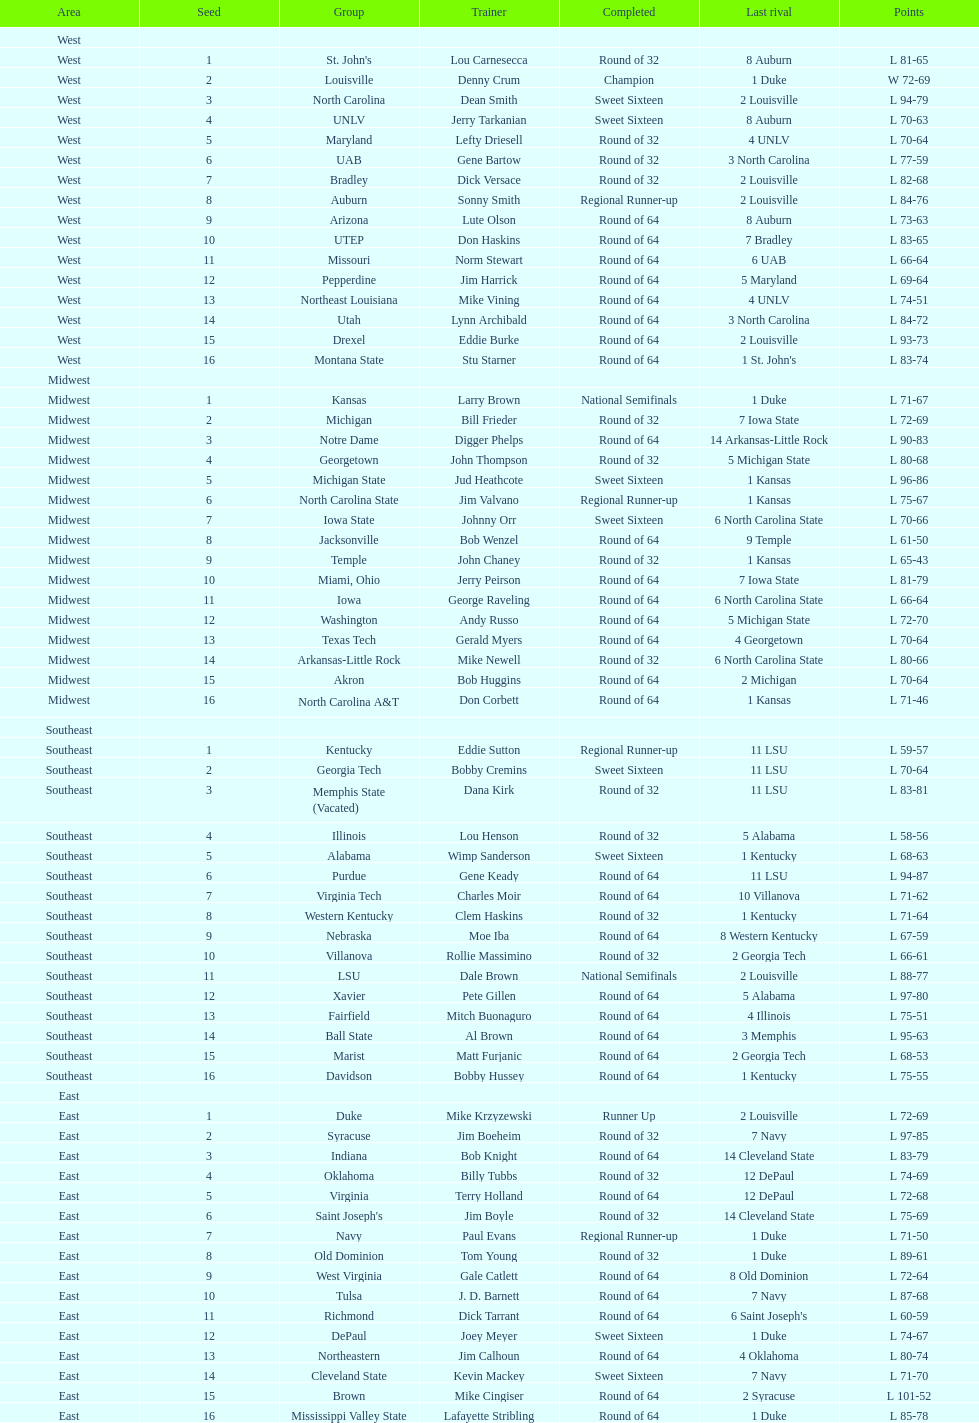How many number of teams played altogether? 64. 